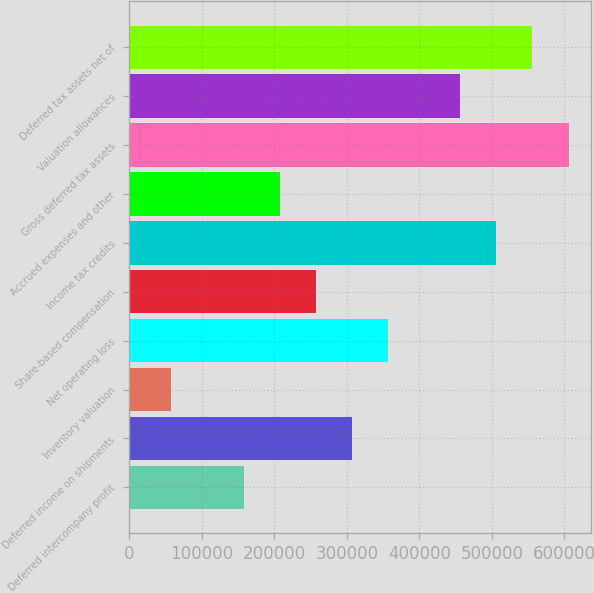Convert chart to OTSL. <chart><loc_0><loc_0><loc_500><loc_500><bar_chart><fcel>Deferred intercompany profit<fcel>Deferred income on shipments<fcel>Inventory valuation<fcel>Net operating loss<fcel>Share-based compensation<fcel>Income tax credits<fcel>Accrued expenses and other<fcel>Gross deferred tax assets<fcel>Valuation allowances<fcel>Deferred tax assets net of<nl><fcel>157812<fcel>307109<fcel>58280.7<fcel>356875<fcel>257344<fcel>506172<fcel>207578<fcel>605703<fcel>456406<fcel>555938<nl></chart> 